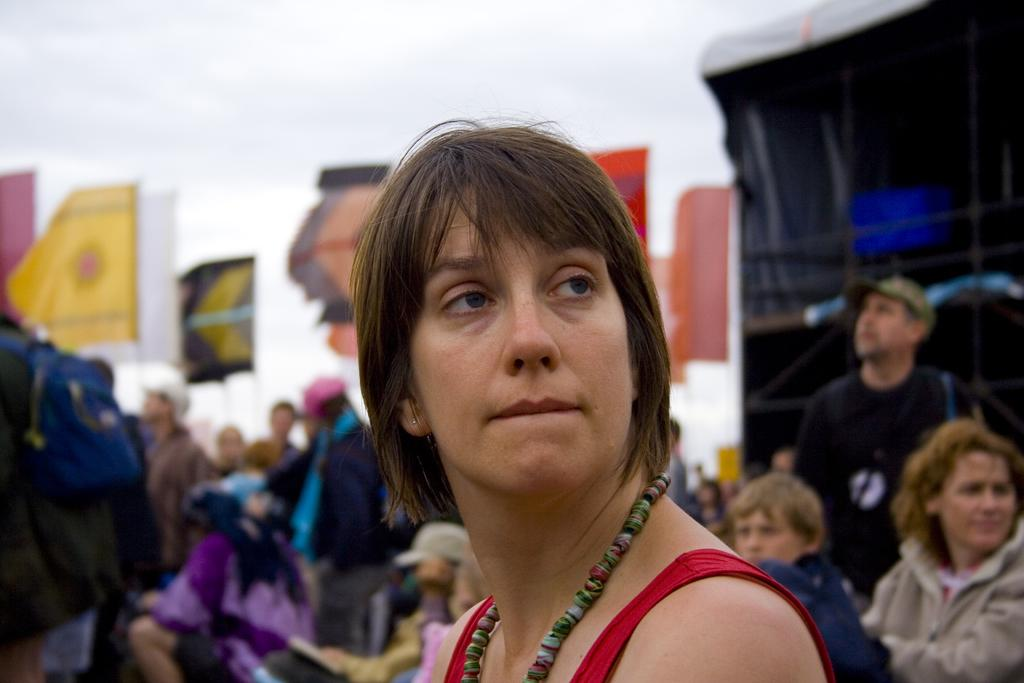Who is present in the image? There is a woman in the image. What can be seen on the backside of the image? Flags are visible on the backside of the image. What type of structure is in the image? There is a wall in the image. What type of club is the woman holding in the image? There is no club present in the image. Is there any smoke visible in the image? There is no smoke present in the image. 